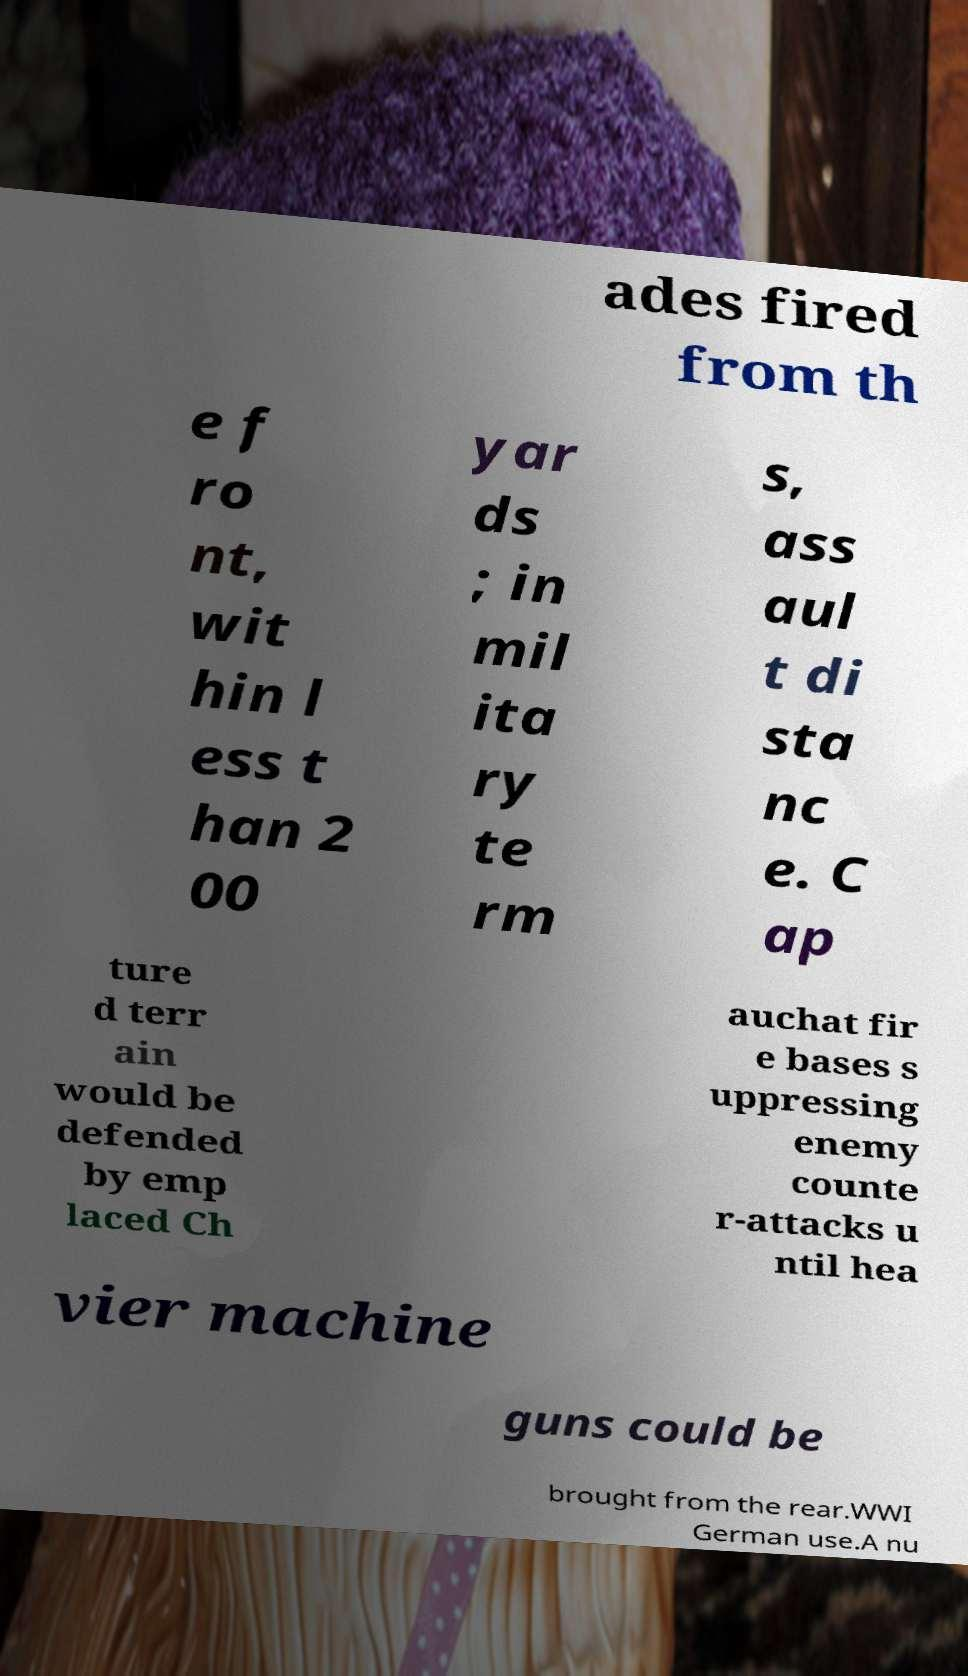What messages or text are displayed in this image? I need them in a readable, typed format. ades fired from th e f ro nt, wit hin l ess t han 2 00 yar ds ; in mil ita ry te rm s, ass aul t di sta nc e. C ap ture d terr ain would be defended by emp laced Ch auchat fir e bases s uppressing enemy counte r-attacks u ntil hea vier machine guns could be brought from the rear.WWI German use.A nu 